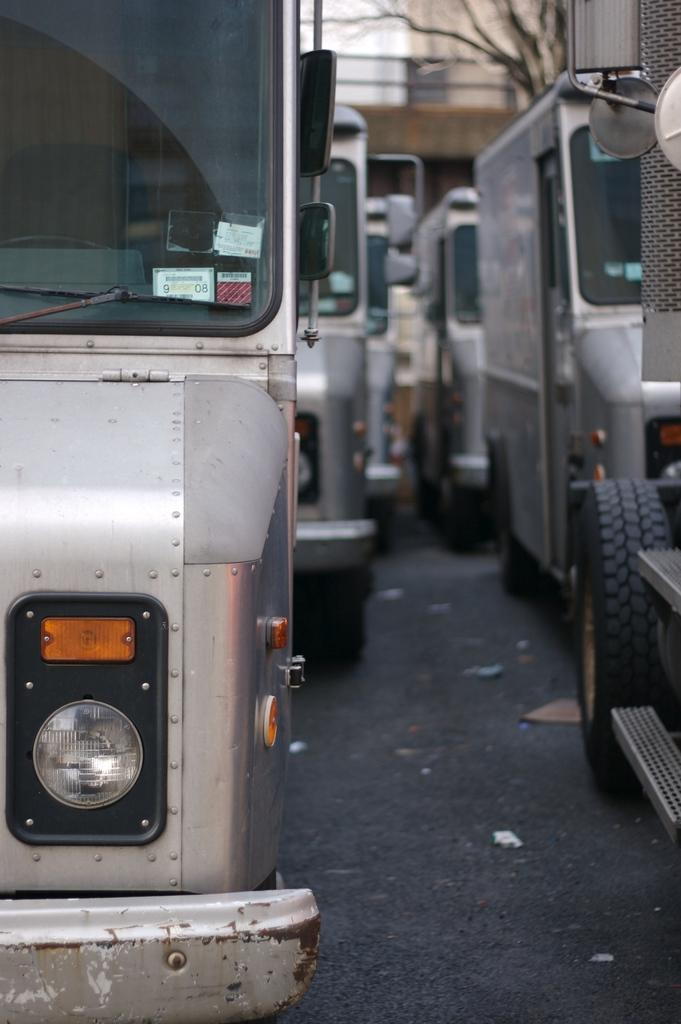What type of vehicles are present in the image? There are vans in the image. Can you describe the vans in the image? The vans are the main subject of the image, but no specific details about their appearance or color are provided. How many vans can be seen in the image? The number of vans in the image is not specified in the provided facts. What type of bird can be seen flying near the vans in the image? There is no bird present in the image; it only features vans. How many rabbits are sitting on top of the vans in the image? There are no rabbits present in the image; it only features vans. 